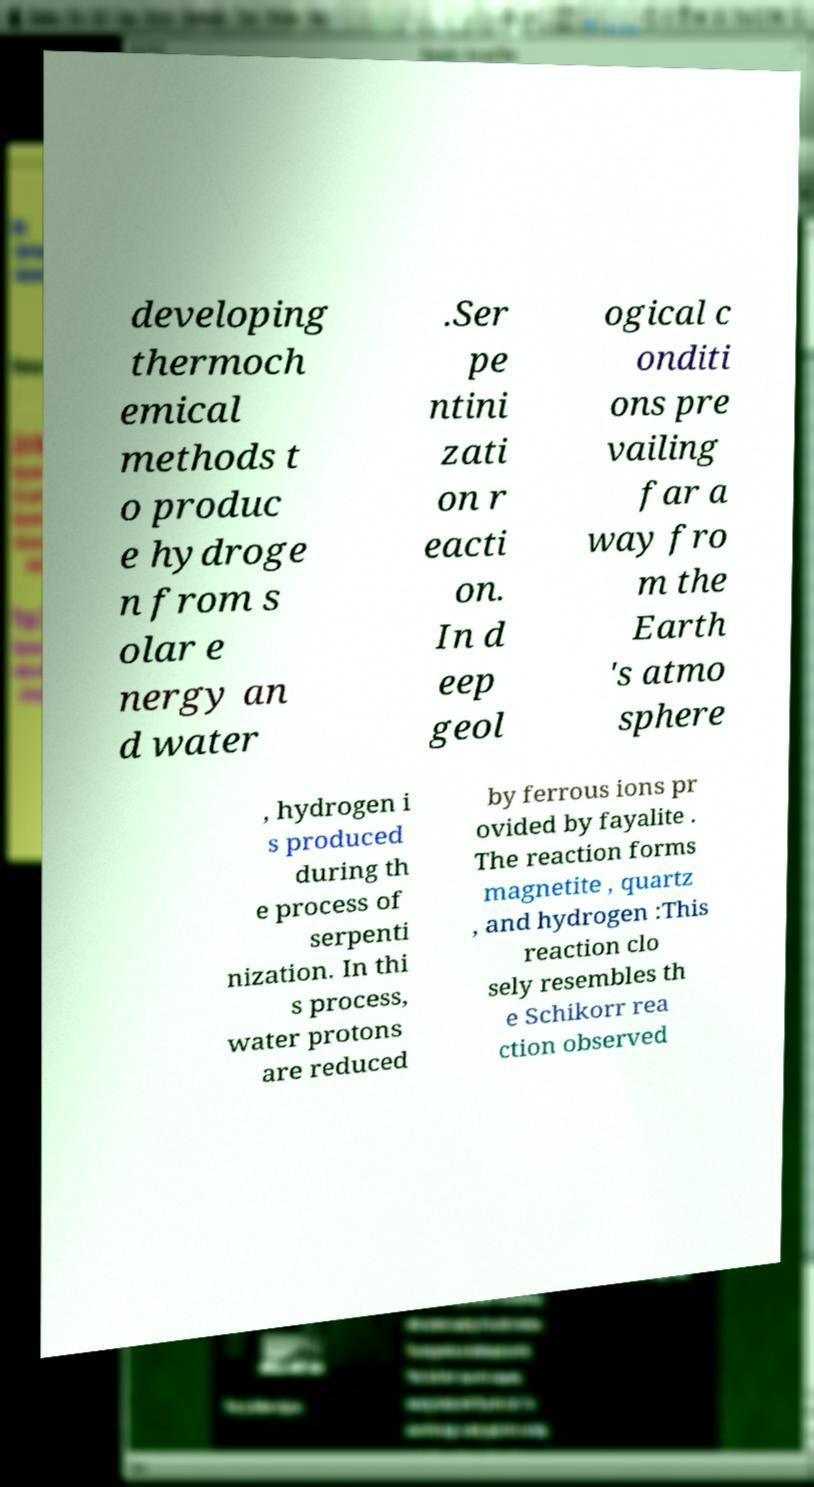I need the written content from this picture converted into text. Can you do that? developing thermoch emical methods t o produc e hydroge n from s olar e nergy an d water .Ser pe ntini zati on r eacti on. In d eep geol ogical c onditi ons pre vailing far a way fro m the Earth 's atmo sphere , hydrogen i s produced during th e process of serpenti nization. In thi s process, water protons are reduced by ferrous ions pr ovided by fayalite . The reaction forms magnetite , quartz , and hydrogen :This reaction clo sely resembles th e Schikorr rea ction observed 